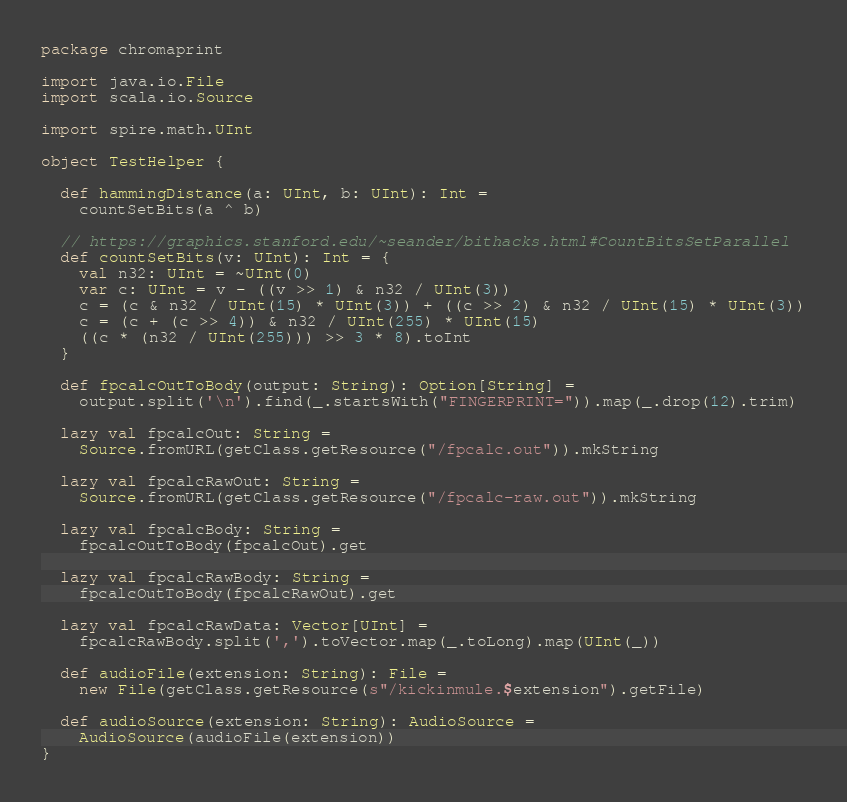Convert code to text. <code><loc_0><loc_0><loc_500><loc_500><_Scala_>package chromaprint

import java.io.File
import scala.io.Source

import spire.math.UInt

object TestHelper {

  def hammingDistance(a: UInt, b: UInt): Int =
    countSetBits(a ^ b)

  // https://graphics.stanford.edu/~seander/bithacks.html#CountBitsSetParallel
  def countSetBits(v: UInt): Int = {
    val n32: UInt = ~UInt(0)
    var c: UInt = v - ((v >> 1) & n32 / UInt(3))
    c = (c & n32 / UInt(15) * UInt(3)) + ((c >> 2) & n32 / UInt(15) * UInt(3))
    c = (c + (c >> 4)) & n32 / UInt(255) * UInt(15)
    ((c * (n32 / UInt(255))) >> 3 * 8).toInt
  }

  def fpcalcOutToBody(output: String): Option[String] =
    output.split('\n').find(_.startsWith("FINGERPRINT=")).map(_.drop(12).trim)

  lazy val fpcalcOut: String =
    Source.fromURL(getClass.getResource("/fpcalc.out")).mkString

  lazy val fpcalcRawOut: String =
    Source.fromURL(getClass.getResource("/fpcalc-raw.out")).mkString

  lazy val fpcalcBody: String =
    fpcalcOutToBody(fpcalcOut).get

  lazy val fpcalcRawBody: String =
    fpcalcOutToBody(fpcalcRawOut).get

  lazy val fpcalcRawData: Vector[UInt] =
    fpcalcRawBody.split(',').toVector.map(_.toLong).map(UInt(_))

  def audioFile(extension: String): File =
    new File(getClass.getResource(s"/kickinmule.$extension").getFile)

  def audioSource(extension: String): AudioSource =
    AudioSource(audioFile(extension))
}
</code> 